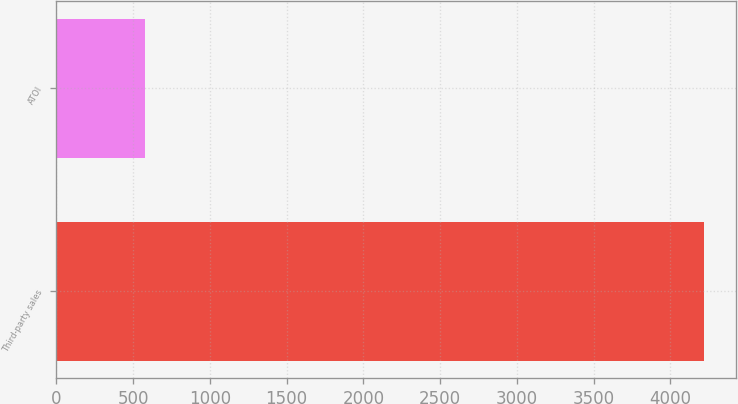Convert chart to OTSL. <chart><loc_0><loc_0><loc_500><loc_500><bar_chart><fcel>Third-party sales<fcel>ATOI<nl><fcel>4217<fcel>579<nl></chart> 